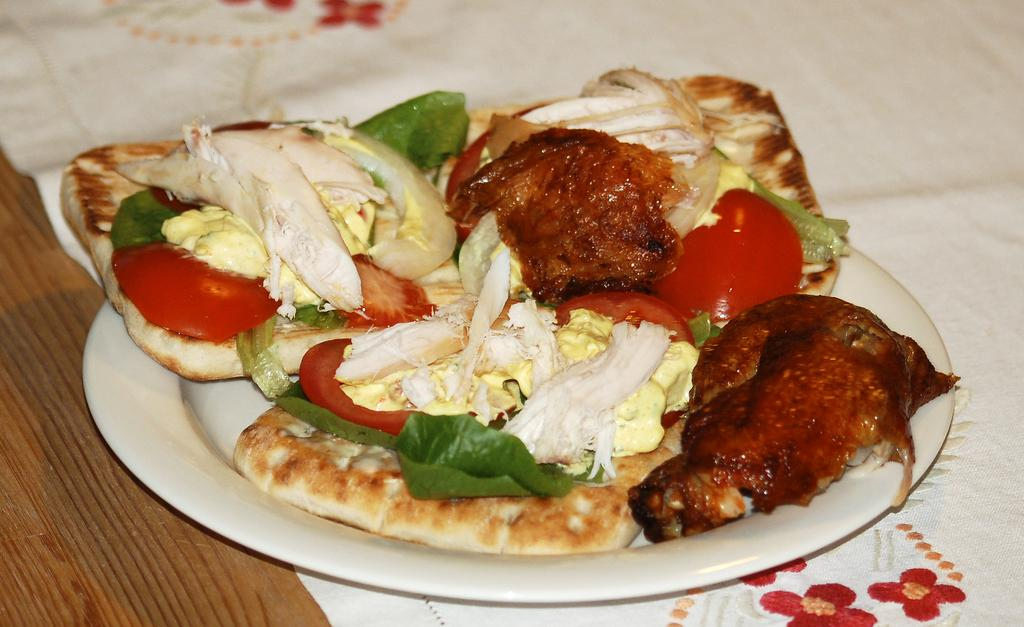What type of surface is visible in the image? There is a wooden surface in the image. What is placed on the wooden surface? There is a cloth with a design on it on the wooden surface. What can be seen on the cloth? There is a plate with food items on the cloth. How many kittens are playing with the orange on the plate? There are no kittens or oranges present in the image. 